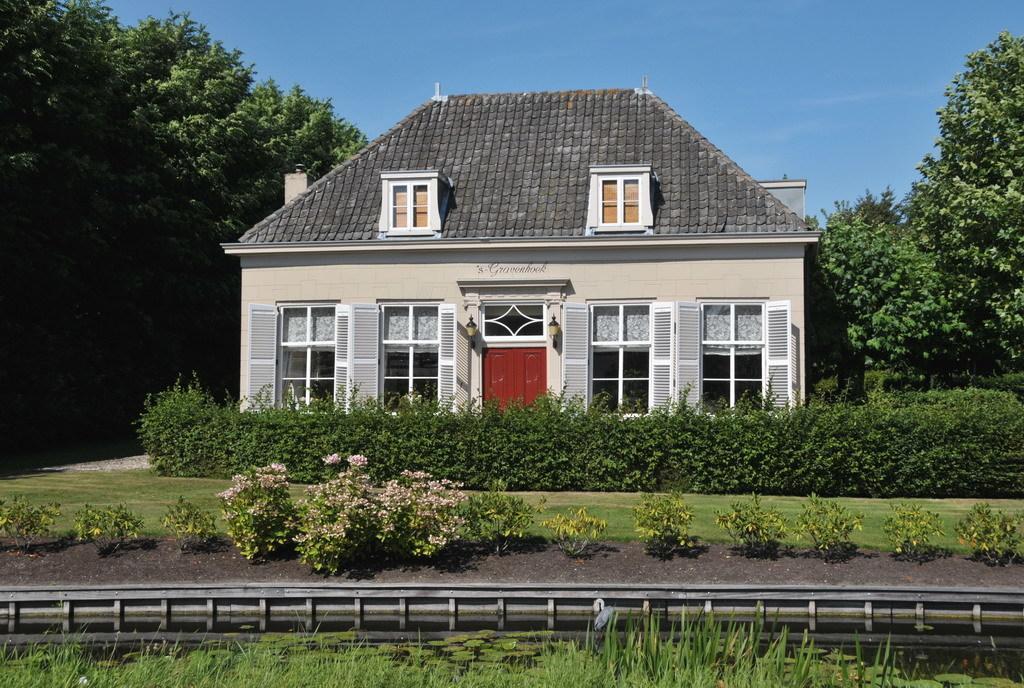Could you give a brief overview of what you see in this image? In this picture there is a house in the center of the image and there are trees on the right and left side of the image, there is grassland at the bottom side of the image. 